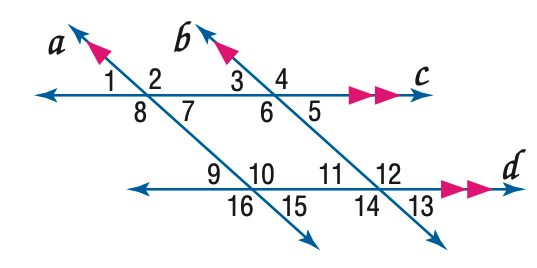Answer the mathemtical geometry problem and directly provide the correct option letter.
Question: In the figure, m \angle 3 = 43. Find the measure of \angle 16.
Choices: A: 117 B: 127 C: 137 D: 147 C 